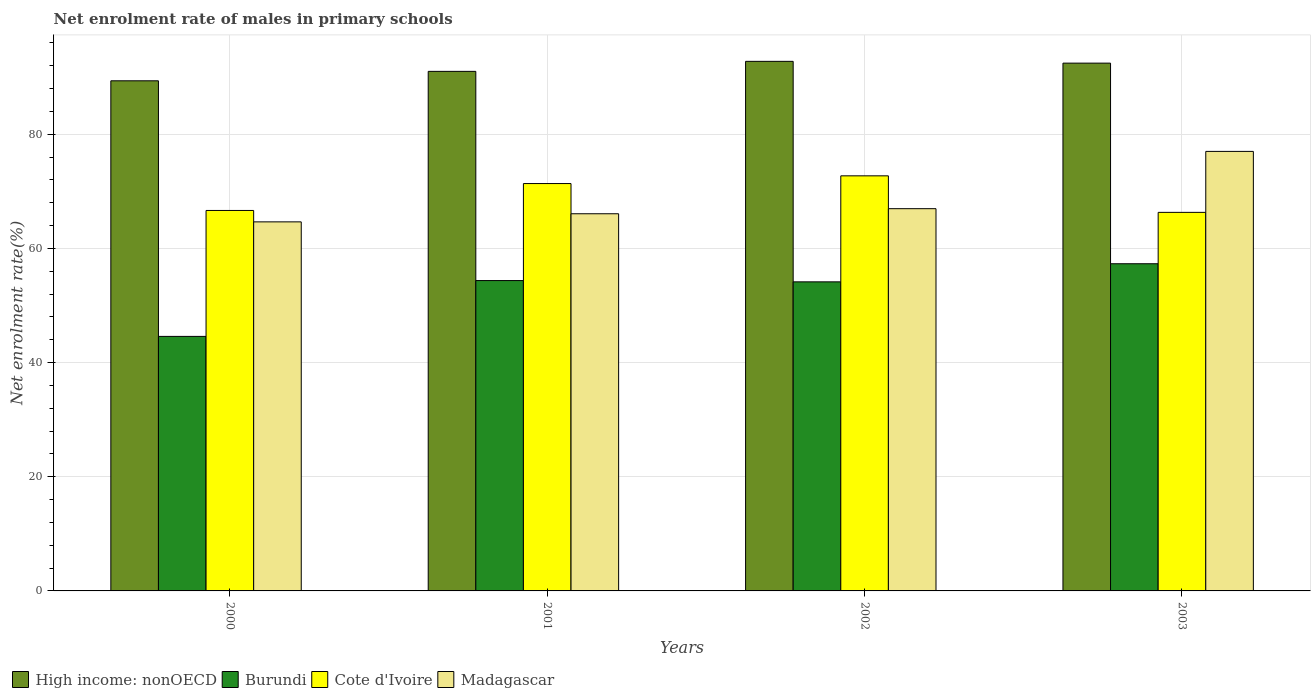How many different coloured bars are there?
Provide a short and direct response. 4. How many groups of bars are there?
Offer a terse response. 4. Are the number of bars on each tick of the X-axis equal?
Provide a succinct answer. Yes. How many bars are there on the 3rd tick from the right?
Make the answer very short. 4. What is the label of the 1st group of bars from the left?
Provide a succinct answer. 2000. In how many cases, is the number of bars for a given year not equal to the number of legend labels?
Keep it short and to the point. 0. What is the net enrolment rate of males in primary schools in Burundi in 2003?
Ensure brevity in your answer.  57.33. Across all years, what is the maximum net enrolment rate of males in primary schools in Burundi?
Your answer should be very brief. 57.33. Across all years, what is the minimum net enrolment rate of males in primary schools in Burundi?
Offer a terse response. 44.59. What is the total net enrolment rate of males in primary schools in Burundi in the graph?
Keep it short and to the point. 210.45. What is the difference between the net enrolment rate of males in primary schools in Burundi in 2000 and that in 2002?
Your answer should be very brief. -9.56. What is the difference between the net enrolment rate of males in primary schools in High income: nonOECD in 2003 and the net enrolment rate of males in primary schools in Cote d'Ivoire in 2001?
Your answer should be compact. 21.1. What is the average net enrolment rate of males in primary schools in High income: nonOECD per year?
Give a very brief answer. 91.42. In the year 2000, what is the difference between the net enrolment rate of males in primary schools in High income: nonOECD and net enrolment rate of males in primary schools in Burundi?
Your answer should be compact. 44.78. What is the ratio of the net enrolment rate of males in primary schools in Cote d'Ivoire in 2000 to that in 2003?
Provide a short and direct response. 1.01. Is the net enrolment rate of males in primary schools in Madagascar in 2000 less than that in 2002?
Your answer should be compact. Yes. What is the difference between the highest and the second highest net enrolment rate of males in primary schools in Cote d'Ivoire?
Your answer should be very brief. 1.35. What is the difference between the highest and the lowest net enrolment rate of males in primary schools in Madagascar?
Offer a terse response. 12.35. In how many years, is the net enrolment rate of males in primary schools in Madagascar greater than the average net enrolment rate of males in primary schools in Madagascar taken over all years?
Your response must be concise. 1. What does the 2nd bar from the left in 2002 represents?
Ensure brevity in your answer.  Burundi. What does the 2nd bar from the right in 2001 represents?
Your answer should be compact. Cote d'Ivoire. How many years are there in the graph?
Keep it short and to the point. 4. What is the difference between two consecutive major ticks on the Y-axis?
Give a very brief answer. 20. Are the values on the major ticks of Y-axis written in scientific E-notation?
Offer a terse response. No. Does the graph contain any zero values?
Offer a very short reply. No. Does the graph contain grids?
Your answer should be compact. Yes. Where does the legend appear in the graph?
Give a very brief answer. Bottom left. What is the title of the graph?
Offer a very short reply. Net enrolment rate of males in primary schools. What is the label or title of the X-axis?
Your answer should be very brief. Years. What is the label or title of the Y-axis?
Keep it short and to the point. Net enrolment rate(%). What is the Net enrolment rate(%) of High income: nonOECD in 2000?
Ensure brevity in your answer.  89.38. What is the Net enrolment rate(%) of Burundi in 2000?
Provide a succinct answer. 44.59. What is the Net enrolment rate(%) in Cote d'Ivoire in 2000?
Your response must be concise. 66.66. What is the Net enrolment rate(%) of Madagascar in 2000?
Give a very brief answer. 64.66. What is the Net enrolment rate(%) of High income: nonOECD in 2001?
Your answer should be very brief. 91.03. What is the Net enrolment rate(%) of Burundi in 2001?
Provide a succinct answer. 54.38. What is the Net enrolment rate(%) in Cote d'Ivoire in 2001?
Provide a succinct answer. 71.37. What is the Net enrolment rate(%) of Madagascar in 2001?
Give a very brief answer. 66.08. What is the Net enrolment rate(%) of High income: nonOECD in 2002?
Your answer should be very brief. 92.78. What is the Net enrolment rate(%) in Burundi in 2002?
Give a very brief answer. 54.15. What is the Net enrolment rate(%) of Cote d'Ivoire in 2002?
Keep it short and to the point. 72.73. What is the Net enrolment rate(%) of Madagascar in 2002?
Your answer should be very brief. 66.97. What is the Net enrolment rate(%) of High income: nonOECD in 2003?
Keep it short and to the point. 92.47. What is the Net enrolment rate(%) of Burundi in 2003?
Provide a short and direct response. 57.33. What is the Net enrolment rate(%) in Cote d'Ivoire in 2003?
Make the answer very short. 66.33. What is the Net enrolment rate(%) of Madagascar in 2003?
Your answer should be compact. 77.01. Across all years, what is the maximum Net enrolment rate(%) in High income: nonOECD?
Offer a terse response. 92.78. Across all years, what is the maximum Net enrolment rate(%) in Burundi?
Provide a short and direct response. 57.33. Across all years, what is the maximum Net enrolment rate(%) of Cote d'Ivoire?
Provide a succinct answer. 72.73. Across all years, what is the maximum Net enrolment rate(%) of Madagascar?
Offer a very short reply. 77.01. Across all years, what is the minimum Net enrolment rate(%) of High income: nonOECD?
Offer a terse response. 89.38. Across all years, what is the minimum Net enrolment rate(%) in Burundi?
Give a very brief answer. 44.59. Across all years, what is the minimum Net enrolment rate(%) of Cote d'Ivoire?
Offer a terse response. 66.33. Across all years, what is the minimum Net enrolment rate(%) of Madagascar?
Your response must be concise. 64.66. What is the total Net enrolment rate(%) in High income: nonOECD in the graph?
Ensure brevity in your answer.  365.66. What is the total Net enrolment rate(%) in Burundi in the graph?
Make the answer very short. 210.45. What is the total Net enrolment rate(%) of Cote d'Ivoire in the graph?
Keep it short and to the point. 277.08. What is the total Net enrolment rate(%) in Madagascar in the graph?
Give a very brief answer. 274.72. What is the difference between the Net enrolment rate(%) in High income: nonOECD in 2000 and that in 2001?
Ensure brevity in your answer.  -1.65. What is the difference between the Net enrolment rate(%) in Burundi in 2000 and that in 2001?
Offer a terse response. -9.78. What is the difference between the Net enrolment rate(%) in Cote d'Ivoire in 2000 and that in 2001?
Offer a very short reply. -4.71. What is the difference between the Net enrolment rate(%) of Madagascar in 2000 and that in 2001?
Provide a succinct answer. -1.42. What is the difference between the Net enrolment rate(%) in High income: nonOECD in 2000 and that in 2002?
Make the answer very short. -3.41. What is the difference between the Net enrolment rate(%) in Burundi in 2000 and that in 2002?
Your answer should be compact. -9.56. What is the difference between the Net enrolment rate(%) in Cote d'Ivoire in 2000 and that in 2002?
Provide a succinct answer. -6.07. What is the difference between the Net enrolment rate(%) of Madagascar in 2000 and that in 2002?
Your answer should be compact. -2.31. What is the difference between the Net enrolment rate(%) of High income: nonOECD in 2000 and that in 2003?
Your response must be concise. -3.09. What is the difference between the Net enrolment rate(%) of Burundi in 2000 and that in 2003?
Offer a very short reply. -12.73. What is the difference between the Net enrolment rate(%) of Cote d'Ivoire in 2000 and that in 2003?
Your response must be concise. 0.33. What is the difference between the Net enrolment rate(%) of Madagascar in 2000 and that in 2003?
Ensure brevity in your answer.  -12.35. What is the difference between the Net enrolment rate(%) in High income: nonOECD in 2001 and that in 2002?
Make the answer very short. -1.75. What is the difference between the Net enrolment rate(%) of Burundi in 2001 and that in 2002?
Give a very brief answer. 0.23. What is the difference between the Net enrolment rate(%) of Cote d'Ivoire in 2001 and that in 2002?
Your response must be concise. -1.35. What is the difference between the Net enrolment rate(%) in Madagascar in 2001 and that in 2002?
Provide a short and direct response. -0.89. What is the difference between the Net enrolment rate(%) in High income: nonOECD in 2001 and that in 2003?
Give a very brief answer. -1.44. What is the difference between the Net enrolment rate(%) of Burundi in 2001 and that in 2003?
Provide a succinct answer. -2.95. What is the difference between the Net enrolment rate(%) of Cote d'Ivoire in 2001 and that in 2003?
Give a very brief answer. 5.05. What is the difference between the Net enrolment rate(%) of Madagascar in 2001 and that in 2003?
Provide a succinct answer. -10.93. What is the difference between the Net enrolment rate(%) of High income: nonOECD in 2002 and that in 2003?
Keep it short and to the point. 0.31. What is the difference between the Net enrolment rate(%) of Burundi in 2002 and that in 2003?
Provide a succinct answer. -3.17. What is the difference between the Net enrolment rate(%) in Cote d'Ivoire in 2002 and that in 2003?
Your answer should be compact. 6.4. What is the difference between the Net enrolment rate(%) in Madagascar in 2002 and that in 2003?
Give a very brief answer. -10.04. What is the difference between the Net enrolment rate(%) in High income: nonOECD in 2000 and the Net enrolment rate(%) in Burundi in 2001?
Ensure brevity in your answer.  35. What is the difference between the Net enrolment rate(%) in High income: nonOECD in 2000 and the Net enrolment rate(%) in Cote d'Ivoire in 2001?
Your answer should be compact. 18. What is the difference between the Net enrolment rate(%) of High income: nonOECD in 2000 and the Net enrolment rate(%) of Madagascar in 2001?
Your response must be concise. 23.3. What is the difference between the Net enrolment rate(%) in Burundi in 2000 and the Net enrolment rate(%) in Cote d'Ivoire in 2001?
Provide a succinct answer. -26.78. What is the difference between the Net enrolment rate(%) of Burundi in 2000 and the Net enrolment rate(%) of Madagascar in 2001?
Make the answer very short. -21.49. What is the difference between the Net enrolment rate(%) in Cote d'Ivoire in 2000 and the Net enrolment rate(%) in Madagascar in 2001?
Offer a terse response. 0.58. What is the difference between the Net enrolment rate(%) in High income: nonOECD in 2000 and the Net enrolment rate(%) in Burundi in 2002?
Provide a succinct answer. 35.23. What is the difference between the Net enrolment rate(%) in High income: nonOECD in 2000 and the Net enrolment rate(%) in Cote d'Ivoire in 2002?
Keep it short and to the point. 16.65. What is the difference between the Net enrolment rate(%) of High income: nonOECD in 2000 and the Net enrolment rate(%) of Madagascar in 2002?
Ensure brevity in your answer.  22.4. What is the difference between the Net enrolment rate(%) in Burundi in 2000 and the Net enrolment rate(%) in Cote d'Ivoire in 2002?
Provide a succinct answer. -28.13. What is the difference between the Net enrolment rate(%) of Burundi in 2000 and the Net enrolment rate(%) of Madagascar in 2002?
Provide a short and direct response. -22.38. What is the difference between the Net enrolment rate(%) of Cote d'Ivoire in 2000 and the Net enrolment rate(%) of Madagascar in 2002?
Make the answer very short. -0.31. What is the difference between the Net enrolment rate(%) of High income: nonOECD in 2000 and the Net enrolment rate(%) of Burundi in 2003?
Ensure brevity in your answer.  32.05. What is the difference between the Net enrolment rate(%) in High income: nonOECD in 2000 and the Net enrolment rate(%) in Cote d'Ivoire in 2003?
Give a very brief answer. 23.05. What is the difference between the Net enrolment rate(%) in High income: nonOECD in 2000 and the Net enrolment rate(%) in Madagascar in 2003?
Ensure brevity in your answer.  12.37. What is the difference between the Net enrolment rate(%) of Burundi in 2000 and the Net enrolment rate(%) of Cote d'Ivoire in 2003?
Keep it short and to the point. -21.73. What is the difference between the Net enrolment rate(%) in Burundi in 2000 and the Net enrolment rate(%) in Madagascar in 2003?
Ensure brevity in your answer.  -32.42. What is the difference between the Net enrolment rate(%) of Cote d'Ivoire in 2000 and the Net enrolment rate(%) of Madagascar in 2003?
Make the answer very short. -10.35. What is the difference between the Net enrolment rate(%) of High income: nonOECD in 2001 and the Net enrolment rate(%) of Burundi in 2002?
Offer a very short reply. 36.88. What is the difference between the Net enrolment rate(%) of High income: nonOECD in 2001 and the Net enrolment rate(%) of Cote d'Ivoire in 2002?
Give a very brief answer. 18.3. What is the difference between the Net enrolment rate(%) of High income: nonOECD in 2001 and the Net enrolment rate(%) of Madagascar in 2002?
Keep it short and to the point. 24.06. What is the difference between the Net enrolment rate(%) of Burundi in 2001 and the Net enrolment rate(%) of Cote d'Ivoire in 2002?
Provide a short and direct response. -18.35. What is the difference between the Net enrolment rate(%) of Burundi in 2001 and the Net enrolment rate(%) of Madagascar in 2002?
Offer a terse response. -12.6. What is the difference between the Net enrolment rate(%) of Cote d'Ivoire in 2001 and the Net enrolment rate(%) of Madagascar in 2002?
Offer a terse response. 4.4. What is the difference between the Net enrolment rate(%) in High income: nonOECD in 2001 and the Net enrolment rate(%) in Burundi in 2003?
Provide a short and direct response. 33.7. What is the difference between the Net enrolment rate(%) in High income: nonOECD in 2001 and the Net enrolment rate(%) in Cote d'Ivoire in 2003?
Keep it short and to the point. 24.7. What is the difference between the Net enrolment rate(%) of High income: nonOECD in 2001 and the Net enrolment rate(%) of Madagascar in 2003?
Keep it short and to the point. 14.02. What is the difference between the Net enrolment rate(%) in Burundi in 2001 and the Net enrolment rate(%) in Cote d'Ivoire in 2003?
Offer a very short reply. -11.95. What is the difference between the Net enrolment rate(%) of Burundi in 2001 and the Net enrolment rate(%) of Madagascar in 2003?
Provide a short and direct response. -22.63. What is the difference between the Net enrolment rate(%) of Cote d'Ivoire in 2001 and the Net enrolment rate(%) of Madagascar in 2003?
Ensure brevity in your answer.  -5.63. What is the difference between the Net enrolment rate(%) of High income: nonOECD in 2002 and the Net enrolment rate(%) of Burundi in 2003?
Offer a very short reply. 35.46. What is the difference between the Net enrolment rate(%) in High income: nonOECD in 2002 and the Net enrolment rate(%) in Cote d'Ivoire in 2003?
Your response must be concise. 26.46. What is the difference between the Net enrolment rate(%) in High income: nonOECD in 2002 and the Net enrolment rate(%) in Madagascar in 2003?
Provide a short and direct response. 15.78. What is the difference between the Net enrolment rate(%) in Burundi in 2002 and the Net enrolment rate(%) in Cote d'Ivoire in 2003?
Your response must be concise. -12.18. What is the difference between the Net enrolment rate(%) in Burundi in 2002 and the Net enrolment rate(%) in Madagascar in 2003?
Ensure brevity in your answer.  -22.86. What is the difference between the Net enrolment rate(%) of Cote d'Ivoire in 2002 and the Net enrolment rate(%) of Madagascar in 2003?
Offer a terse response. -4.28. What is the average Net enrolment rate(%) in High income: nonOECD per year?
Provide a short and direct response. 91.42. What is the average Net enrolment rate(%) in Burundi per year?
Your answer should be compact. 52.61. What is the average Net enrolment rate(%) in Cote d'Ivoire per year?
Give a very brief answer. 69.27. What is the average Net enrolment rate(%) of Madagascar per year?
Your response must be concise. 68.68. In the year 2000, what is the difference between the Net enrolment rate(%) of High income: nonOECD and Net enrolment rate(%) of Burundi?
Provide a succinct answer. 44.78. In the year 2000, what is the difference between the Net enrolment rate(%) in High income: nonOECD and Net enrolment rate(%) in Cote d'Ivoire?
Make the answer very short. 22.72. In the year 2000, what is the difference between the Net enrolment rate(%) of High income: nonOECD and Net enrolment rate(%) of Madagascar?
Provide a succinct answer. 24.72. In the year 2000, what is the difference between the Net enrolment rate(%) of Burundi and Net enrolment rate(%) of Cote d'Ivoire?
Provide a short and direct response. -22.07. In the year 2000, what is the difference between the Net enrolment rate(%) in Burundi and Net enrolment rate(%) in Madagascar?
Your response must be concise. -20.07. In the year 2000, what is the difference between the Net enrolment rate(%) in Cote d'Ivoire and Net enrolment rate(%) in Madagascar?
Provide a short and direct response. 2. In the year 2001, what is the difference between the Net enrolment rate(%) in High income: nonOECD and Net enrolment rate(%) in Burundi?
Keep it short and to the point. 36.65. In the year 2001, what is the difference between the Net enrolment rate(%) in High income: nonOECD and Net enrolment rate(%) in Cote d'Ivoire?
Your response must be concise. 19.66. In the year 2001, what is the difference between the Net enrolment rate(%) of High income: nonOECD and Net enrolment rate(%) of Madagascar?
Your answer should be very brief. 24.95. In the year 2001, what is the difference between the Net enrolment rate(%) in Burundi and Net enrolment rate(%) in Cote d'Ivoire?
Give a very brief answer. -17. In the year 2001, what is the difference between the Net enrolment rate(%) of Burundi and Net enrolment rate(%) of Madagascar?
Provide a short and direct response. -11.71. In the year 2001, what is the difference between the Net enrolment rate(%) of Cote d'Ivoire and Net enrolment rate(%) of Madagascar?
Keep it short and to the point. 5.29. In the year 2002, what is the difference between the Net enrolment rate(%) of High income: nonOECD and Net enrolment rate(%) of Burundi?
Your answer should be compact. 38.63. In the year 2002, what is the difference between the Net enrolment rate(%) of High income: nonOECD and Net enrolment rate(%) of Cote d'Ivoire?
Offer a very short reply. 20.06. In the year 2002, what is the difference between the Net enrolment rate(%) of High income: nonOECD and Net enrolment rate(%) of Madagascar?
Your answer should be very brief. 25.81. In the year 2002, what is the difference between the Net enrolment rate(%) of Burundi and Net enrolment rate(%) of Cote d'Ivoire?
Provide a succinct answer. -18.57. In the year 2002, what is the difference between the Net enrolment rate(%) in Burundi and Net enrolment rate(%) in Madagascar?
Your answer should be compact. -12.82. In the year 2002, what is the difference between the Net enrolment rate(%) of Cote d'Ivoire and Net enrolment rate(%) of Madagascar?
Ensure brevity in your answer.  5.75. In the year 2003, what is the difference between the Net enrolment rate(%) in High income: nonOECD and Net enrolment rate(%) in Burundi?
Offer a terse response. 35.15. In the year 2003, what is the difference between the Net enrolment rate(%) of High income: nonOECD and Net enrolment rate(%) of Cote d'Ivoire?
Your answer should be compact. 26.15. In the year 2003, what is the difference between the Net enrolment rate(%) in High income: nonOECD and Net enrolment rate(%) in Madagascar?
Ensure brevity in your answer.  15.46. In the year 2003, what is the difference between the Net enrolment rate(%) of Burundi and Net enrolment rate(%) of Cote d'Ivoire?
Make the answer very short. -9. In the year 2003, what is the difference between the Net enrolment rate(%) in Burundi and Net enrolment rate(%) in Madagascar?
Give a very brief answer. -19.68. In the year 2003, what is the difference between the Net enrolment rate(%) in Cote d'Ivoire and Net enrolment rate(%) in Madagascar?
Ensure brevity in your answer.  -10.68. What is the ratio of the Net enrolment rate(%) in High income: nonOECD in 2000 to that in 2001?
Offer a terse response. 0.98. What is the ratio of the Net enrolment rate(%) in Burundi in 2000 to that in 2001?
Your answer should be very brief. 0.82. What is the ratio of the Net enrolment rate(%) of Cote d'Ivoire in 2000 to that in 2001?
Your answer should be very brief. 0.93. What is the ratio of the Net enrolment rate(%) of Madagascar in 2000 to that in 2001?
Give a very brief answer. 0.98. What is the ratio of the Net enrolment rate(%) in High income: nonOECD in 2000 to that in 2002?
Ensure brevity in your answer.  0.96. What is the ratio of the Net enrolment rate(%) of Burundi in 2000 to that in 2002?
Offer a terse response. 0.82. What is the ratio of the Net enrolment rate(%) of Cote d'Ivoire in 2000 to that in 2002?
Ensure brevity in your answer.  0.92. What is the ratio of the Net enrolment rate(%) in Madagascar in 2000 to that in 2002?
Offer a terse response. 0.97. What is the ratio of the Net enrolment rate(%) in High income: nonOECD in 2000 to that in 2003?
Your answer should be compact. 0.97. What is the ratio of the Net enrolment rate(%) in Burundi in 2000 to that in 2003?
Your answer should be compact. 0.78. What is the ratio of the Net enrolment rate(%) in Cote d'Ivoire in 2000 to that in 2003?
Your answer should be compact. 1. What is the ratio of the Net enrolment rate(%) of Madagascar in 2000 to that in 2003?
Your answer should be very brief. 0.84. What is the ratio of the Net enrolment rate(%) of High income: nonOECD in 2001 to that in 2002?
Keep it short and to the point. 0.98. What is the ratio of the Net enrolment rate(%) in Burundi in 2001 to that in 2002?
Offer a very short reply. 1. What is the ratio of the Net enrolment rate(%) of Cote d'Ivoire in 2001 to that in 2002?
Provide a short and direct response. 0.98. What is the ratio of the Net enrolment rate(%) in Madagascar in 2001 to that in 2002?
Give a very brief answer. 0.99. What is the ratio of the Net enrolment rate(%) in High income: nonOECD in 2001 to that in 2003?
Your answer should be compact. 0.98. What is the ratio of the Net enrolment rate(%) in Burundi in 2001 to that in 2003?
Ensure brevity in your answer.  0.95. What is the ratio of the Net enrolment rate(%) in Cote d'Ivoire in 2001 to that in 2003?
Offer a very short reply. 1.08. What is the ratio of the Net enrolment rate(%) of Madagascar in 2001 to that in 2003?
Give a very brief answer. 0.86. What is the ratio of the Net enrolment rate(%) of High income: nonOECD in 2002 to that in 2003?
Ensure brevity in your answer.  1. What is the ratio of the Net enrolment rate(%) of Burundi in 2002 to that in 2003?
Provide a short and direct response. 0.94. What is the ratio of the Net enrolment rate(%) of Cote d'Ivoire in 2002 to that in 2003?
Ensure brevity in your answer.  1.1. What is the ratio of the Net enrolment rate(%) in Madagascar in 2002 to that in 2003?
Your answer should be compact. 0.87. What is the difference between the highest and the second highest Net enrolment rate(%) of High income: nonOECD?
Your response must be concise. 0.31. What is the difference between the highest and the second highest Net enrolment rate(%) in Burundi?
Keep it short and to the point. 2.95. What is the difference between the highest and the second highest Net enrolment rate(%) of Cote d'Ivoire?
Offer a terse response. 1.35. What is the difference between the highest and the second highest Net enrolment rate(%) of Madagascar?
Your answer should be compact. 10.04. What is the difference between the highest and the lowest Net enrolment rate(%) of High income: nonOECD?
Your answer should be compact. 3.41. What is the difference between the highest and the lowest Net enrolment rate(%) of Burundi?
Provide a short and direct response. 12.73. What is the difference between the highest and the lowest Net enrolment rate(%) in Cote d'Ivoire?
Keep it short and to the point. 6.4. What is the difference between the highest and the lowest Net enrolment rate(%) of Madagascar?
Make the answer very short. 12.35. 